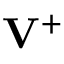Convert formula to latex. <formula><loc_0><loc_0><loc_500><loc_500>{ V } ^ { + }</formula> 